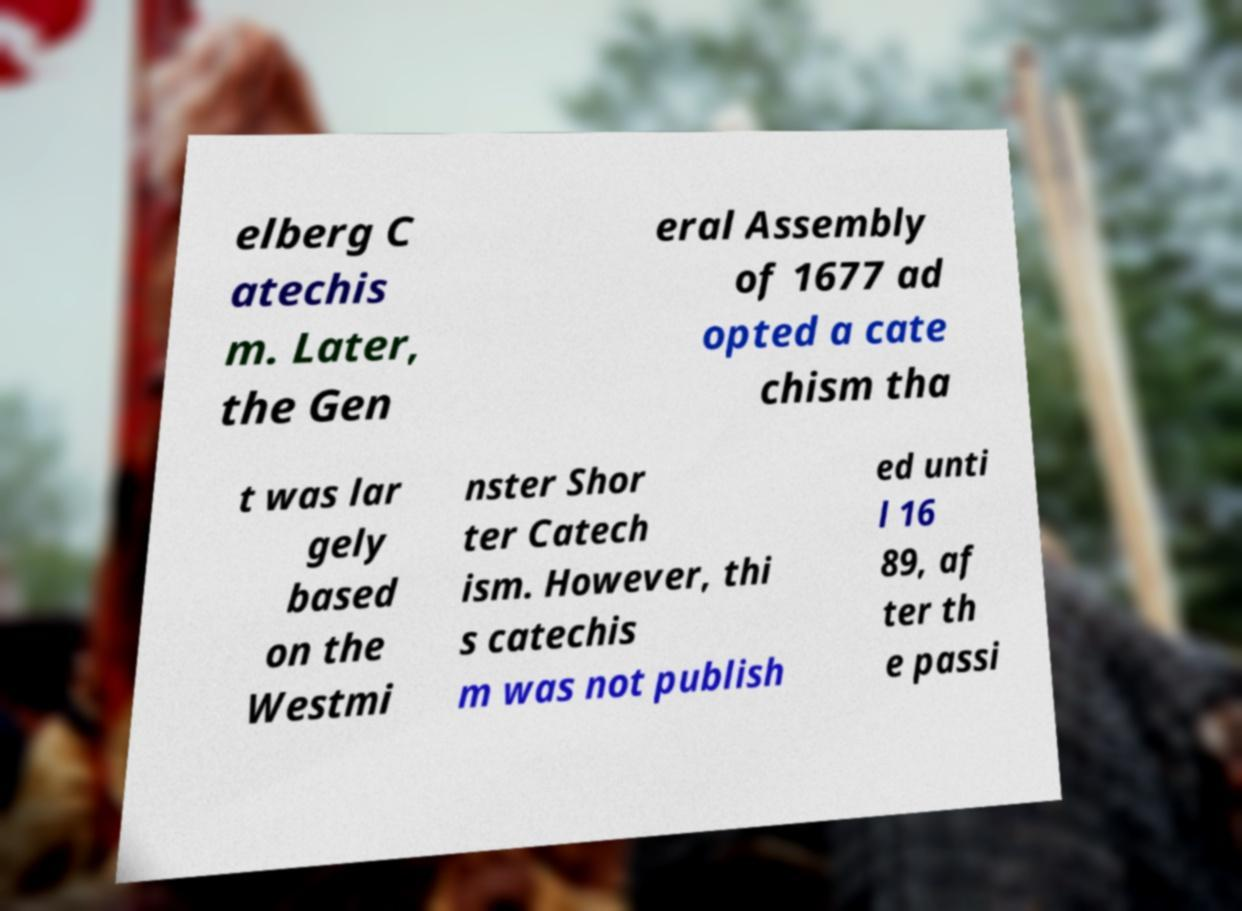Can you accurately transcribe the text from the provided image for me? elberg C atechis m. Later, the Gen eral Assembly of 1677 ad opted a cate chism tha t was lar gely based on the Westmi nster Shor ter Catech ism. However, thi s catechis m was not publish ed unti l 16 89, af ter th e passi 